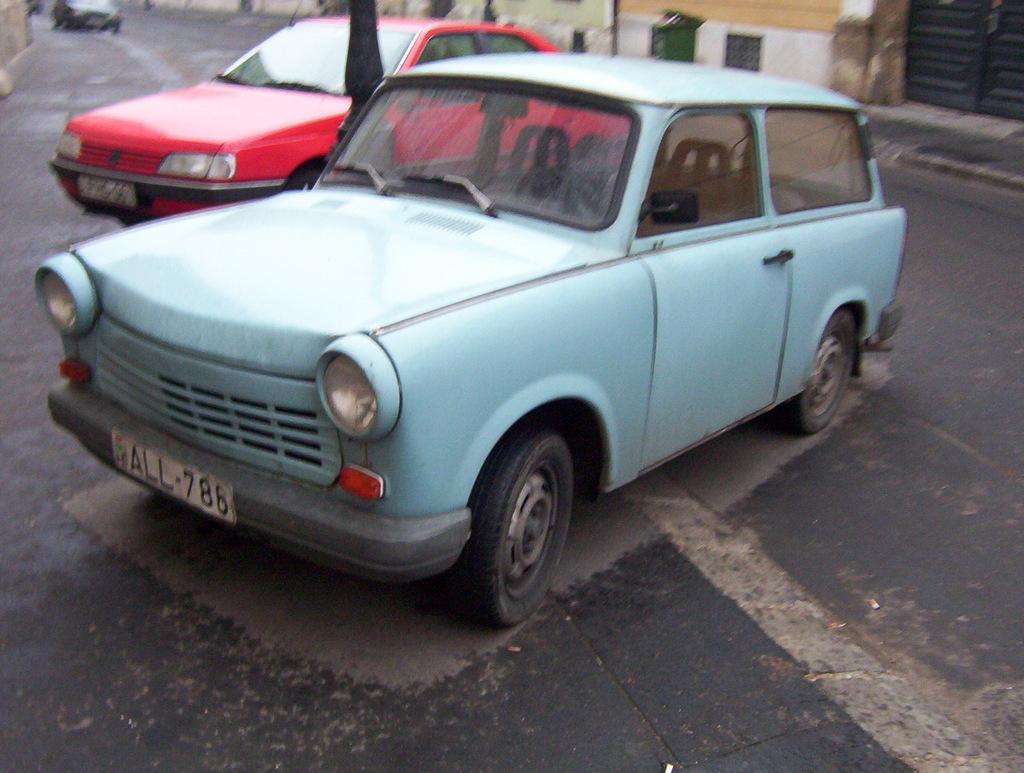Please provide a concise description of this image. In this image there is a road on which there are two cars in the middle. In the background there is another car on the road. There are buildings on either side of the road. In between the two cars there is a pole. 